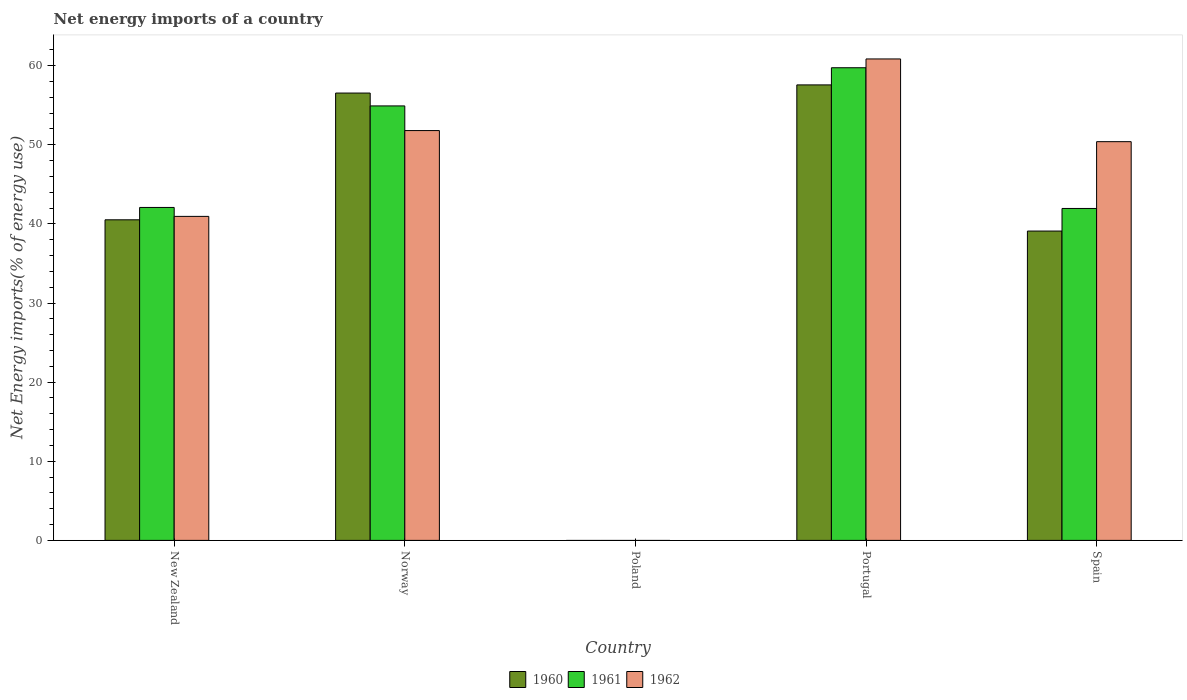Are the number of bars per tick equal to the number of legend labels?
Provide a succinct answer. No. What is the net energy imports in 1962 in New Zealand?
Offer a very short reply. 40.95. Across all countries, what is the maximum net energy imports in 1961?
Keep it short and to the point. 59.74. What is the total net energy imports in 1960 in the graph?
Make the answer very short. 193.74. What is the difference between the net energy imports in 1961 in New Zealand and that in Norway?
Ensure brevity in your answer.  -12.83. What is the difference between the net energy imports in 1962 in Poland and the net energy imports in 1961 in New Zealand?
Keep it short and to the point. -42.08. What is the average net energy imports in 1960 per country?
Your response must be concise. 38.75. What is the difference between the net energy imports of/in 1960 and net energy imports of/in 1962 in Norway?
Make the answer very short. 4.74. What is the ratio of the net energy imports in 1962 in Norway to that in Spain?
Ensure brevity in your answer.  1.03. Is the difference between the net energy imports in 1960 in New Zealand and Portugal greater than the difference between the net energy imports in 1962 in New Zealand and Portugal?
Keep it short and to the point. Yes. What is the difference between the highest and the second highest net energy imports in 1961?
Offer a terse response. -17.66. What is the difference between the highest and the lowest net energy imports in 1960?
Make the answer very short. 57.57. Are the values on the major ticks of Y-axis written in scientific E-notation?
Make the answer very short. No. Does the graph contain any zero values?
Your answer should be compact. Yes. What is the title of the graph?
Keep it short and to the point. Net energy imports of a country. Does "1977" appear as one of the legend labels in the graph?
Keep it short and to the point. No. What is the label or title of the X-axis?
Offer a very short reply. Country. What is the label or title of the Y-axis?
Ensure brevity in your answer.  Net Energy imports(% of energy use). What is the Net Energy imports(% of energy use) of 1960 in New Zealand?
Ensure brevity in your answer.  40.52. What is the Net Energy imports(% of energy use) in 1961 in New Zealand?
Your answer should be very brief. 42.08. What is the Net Energy imports(% of energy use) of 1962 in New Zealand?
Give a very brief answer. 40.95. What is the Net Energy imports(% of energy use) of 1960 in Norway?
Provide a short and direct response. 56.54. What is the Net Energy imports(% of energy use) of 1961 in Norway?
Give a very brief answer. 54.92. What is the Net Energy imports(% of energy use) of 1962 in Norway?
Your answer should be very brief. 51.8. What is the Net Energy imports(% of energy use) of 1960 in Poland?
Offer a very short reply. 0. What is the Net Energy imports(% of energy use) of 1961 in Poland?
Ensure brevity in your answer.  0. What is the Net Energy imports(% of energy use) of 1960 in Portugal?
Make the answer very short. 57.57. What is the Net Energy imports(% of energy use) of 1961 in Portugal?
Your response must be concise. 59.74. What is the Net Energy imports(% of energy use) in 1962 in Portugal?
Your answer should be very brief. 60.85. What is the Net Energy imports(% of energy use) in 1960 in Spain?
Provide a succinct answer. 39.1. What is the Net Energy imports(% of energy use) of 1961 in Spain?
Make the answer very short. 41.95. What is the Net Energy imports(% of energy use) of 1962 in Spain?
Give a very brief answer. 50.4. Across all countries, what is the maximum Net Energy imports(% of energy use) of 1960?
Ensure brevity in your answer.  57.57. Across all countries, what is the maximum Net Energy imports(% of energy use) in 1961?
Ensure brevity in your answer.  59.74. Across all countries, what is the maximum Net Energy imports(% of energy use) in 1962?
Your answer should be compact. 60.85. Across all countries, what is the minimum Net Energy imports(% of energy use) of 1960?
Make the answer very short. 0. Across all countries, what is the minimum Net Energy imports(% of energy use) in 1961?
Keep it short and to the point. 0. What is the total Net Energy imports(% of energy use) in 1960 in the graph?
Your answer should be compact. 193.74. What is the total Net Energy imports(% of energy use) in 1961 in the graph?
Ensure brevity in your answer.  198.7. What is the total Net Energy imports(% of energy use) in 1962 in the graph?
Ensure brevity in your answer.  204.01. What is the difference between the Net Energy imports(% of energy use) of 1960 in New Zealand and that in Norway?
Give a very brief answer. -16.02. What is the difference between the Net Energy imports(% of energy use) of 1961 in New Zealand and that in Norway?
Make the answer very short. -12.83. What is the difference between the Net Energy imports(% of energy use) of 1962 in New Zealand and that in Norway?
Your response must be concise. -10.85. What is the difference between the Net Energy imports(% of energy use) in 1960 in New Zealand and that in Portugal?
Offer a terse response. -17.05. What is the difference between the Net Energy imports(% of energy use) of 1961 in New Zealand and that in Portugal?
Ensure brevity in your answer.  -17.66. What is the difference between the Net Energy imports(% of energy use) of 1962 in New Zealand and that in Portugal?
Your response must be concise. -19.9. What is the difference between the Net Energy imports(% of energy use) in 1960 in New Zealand and that in Spain?
Give a very brief answer. 1.42. What is the difference between the Net Energy imports(% of energy use) of 1961 in New Zealand and that in Spain?
Provide a short and direct response. 0.13. What is the difference between the Net Energy imports(% of energy use) of 1962 in New Zealand and that in Spain?
Give a very brief answer. -9.45. What is the difference between the Net Energy imports(% of energy use) of 1960 in Norway and that in Portugal?
Give a very brief answer. -1.03. What is the difference between the Net Energy imports(% of energy use) in 1961 in Norway and that in Portugal?
Offer a very short reply. -4.83. What is the difference between the Net Energy imports(% of energy use) in 1962 in Norway and that in Portugal?
Offer a very short reply. -9.05. What is the difference between the Net Energy imports(% of energy use) in 1960 in Norway and that in Spain?
Offer a very short reply. 17.44. What is the difference between the Net Energy imports(% of energy use) in 1961 in Norway and that in Spain?
Offer a very short reply. 12.96. What is the difference between the Net Energy imports(% of energy use) of 1962 in Norway and that in Spain?
Offer a very short reply. 1.4. What is the difference between the Net Energy imports(% of energy use) of 1960 in Portugal and that in Spain?
Ensure brevity in your answer.  18.47. What is the difference between the Net Energy imports(% of energy use) in 1961 in Portugal and that in Spain?
Offer a terse response. 17.79. What is the difference between the Net Energy imports(% of energy use) in 1962 in Portugal and that in Spain?
Offer a terse response. 10.46. What is the difference between the Net Energy imports(% of energy use) in 1960 in New Zealand and the Net Energy imports(% of energy use) in 1961 in Norway?
Your answer should be very brief. -14.39. What is the difference between the Net Energy imports(% of energy use) in 1960 in New Zealand and the Net Energy imports(% of energy use) in 1962 in Norway?
Offer a very short reply. -11.28. What is the difference between the Net Energy imports(% of energy use) in 1961 in New Zealand and the Net Energy imports(% of energy use) in 1962 in Norway?
Keep it short and to the point. -9.72. What is the difference between the Net Energy imports(% of energy use) of 1960 in New Zealand and the Net Energy imports(% of energy use) of 1961 in Portugal?
Keep it short and to the point. -19.22. What is the difference between the Net Energy imports(% of energy use) in 1960 in New Zealand and the Net Energy imports(% of energy use) in 1962 in Portugal?
Offer a terse response. -20.33. What is the difference between the Net Energy imports(% of energy use) of 1961 in New Zealand and the Net Energy imports(% of energy use) of 1962 in Portugal?
Ensure brevity in your answer.  -18.77. What is the difference between the Net Energy imports(% of energy use) in 1960 in New Zealand and the Net Energy imports(% of energy use) in 1961 in Spain?
Ensure brevity in your answer.  -1.43. What is the difference between the Net Energy imports(% of energy use) of 1960 in New Zealand and the Net Energy imports(% of energy use) of 1962 in Spain?
Your response must be concise. -9.88. What is the difference between the Net Energy imports(% of energy use) in 1961 in New Zealand and the Net Energy imports(% of energy use) in 1962 in Spain?
Your response must be concise. -8.32. What is the difference between the Net Energy imports(% of energy use) in 1960 in Norway and the Net Energy imports(% of energy use) in 1961 in Portugal?
Your response must be concise. -3.2. What is the difference between the Net Energy imports(% of energy use) in 1960 in Norway and the Net Energy imports(% of energy use) in 1962 in Portugal?
Offer a very short reply. -4.31. What is the difference between the Net Energy imports(% of energy use) of 1961 in Norway and the Net Energy imports(% of energy use) of 1962 in Portugal?
Give a very brief answer. -5.94. What is the difference between the Net Energy imports(% of energy use) of 1960 in Norway and the Net Energy imports(% of energy use) of 1961 in Spain?
Provide a succinct answer. 14.59. What is the difference between the Net Energy imports(% of energy use) of 1960 in Norway and the Net Energy imports(% of energy use) of 1962 in Spain?
Keep it short and to the point. 6.14. What is the difference between the Net Energy imports(% of energy use) in 1961 in Norway and the Net Energy imports(% of energy use) in 1962 in Spain?
Your answer should be compact. 4.52. What is the difference between the Net Energy imports(% of energy use) in 1960 in Portugal and the Net Energy imports(% of energy use) in 1961 in Spain?
Your response must be concise. 15.62. What is the difference between the Net Energy imports(% of energy use) in 1960 in Portugal and the Net Energy imports(% of energy use) in 1962 in Spain?
Provide a succinct answer. 7.18. What is the difference between the Net Energy imports(% of energy use) of 1961 in Portugal and the Net Energy imports(% of energy use) of 1962 in Spain?
Your response must be concise. 9.34. What is the average Net Energy imports(% of energy use) in 1960 per country?
Make the answer very short. 38.75. What is the average Net Energy imports(% of energy use) in 1961 per country?
Offer a very short reply. 39.74. What is the average Net Energy imports(% of energy use) in 1962 per country?
Ensure brevity in your answer.  40.8. What is the difference between the Net Energy imports(% of energy use) in 1960 and Net Energy imports(% of energy use) in 1961 in New Zealand?
Make the answer very short. -1.56. What is the difference between the Net Energy imports(% of energy use) of 1960 and Net Energy imports(% of energy use) of 1962 in New Zealand?
Keep it short and to the point. -0.43. What is the difference between the Net Energy imports(% of energy use) of 1961 and Net Energy imports(% of energy use) of 1962 in New Zealand?
Provide a short and direct response. 1.13. What is the difference between the Net Energy imports(% of energy use) of 1960 and Net Energy imports(% of energy use) of 1961 in Norway?
Your response must be concise. 1.62. What is the difference between the Net Energy imports(% of energy use) of 1960 and Net Energy imports(% of energy use) of 1962 in Norway?
Give a very brief answer. 4.74. What is the difference between the Net Energy imports(% of energy use) in 1961 and Net Energy imports(% of energy use) in 1962 in Norway?
Keep it short and to the point. 3.12. What is the difference between the Net Energy imports(% of energy use) of 1960 and Net Energy imports(% of energy use) of 1961 in Portugal?
Give a very brief answer. -2.17. What is the difference between the Net Energy imports(% of energy use) in 1960 and Net Energy imports(% of energy use) in 1962 in Portugal?
Provide a succinct answer. -3.28. What is the difference between the Net Energy imports(% of energy use) in 1961 and Net Energy imports(% of energy use) in 1962 in Portugal?
Your answer should be very brief. -1.11. What is the difference between the Net Energy imports(% of energy use) in 1960 and Net Energy imports(% of energy use) in 1961 in Spain?
Ensure brevity in your answer.  -2.85. What is the difference between the Net Energy imports(% of energy use) in 1960 and Net Energy imports(% of energy use) in 1962 in Spain?
Provide a succinct answer. -11.3. What is the difference between the Net Energy imports(% of energy use) in 1961 and Net Energy imports(% of energy use) in 1962 in Spain?
Your response must be concise. -8.44. What is the ratio of the Net Energy imports(% of energy use) in 1960 in New Zealand to that in Norway?
Give a very brief answer. 0.72. What is the ratio of the Net Energy imports(% of energy use) in 1961 in New Zealand to that in Norway?
Ensure brevity in your answer.  0.77. What is the ratio of the Net Energy imports(% of energy use) of 1962 in New Zealand to that in Norway?
Your answer should be very brief. 0.79. What is the ratio of the Net Energy imports(% of energy use) in 1960 in New Zealand to that in Portugal?
Your response must be concise. 0.7. What is the ratio of the Net Energy imports(% of energy use) in 1961 in New Zealand to that in Portugal?
Keep it short and to the point. 0.7. What is the ratio of the Net Energy imports(% of energy use) in 1962 in New Zealand to that in Portugal?
Make the answer very short. 0.67. What is the ratio of the Net Energy imports(% of energy use) of 1960 in New Zealand to that in Spain?
Your answer should be very brief. 1.04. What is the ratio of the Net Energy imports(% of energy use) of 1961 in New Zealand to that in Spain?
Provide a succinct answer. 1. What is the ratio of the Net Energy imports(% of energy use) in 1962 in New Zealand to that in Spain?
Your answer should be very brief. 0.81. What is the ratio of the Net Energy imports(% of energy use) in 1960 in Norway to that in Portugal?
Provide a short and direct response. 0.98. What is the ratio of the Net Energy imports(% of energy use) of 1961 in Norway to that in Portugal?
Provide a short and direct response. 0.92. What is the ratio of the Net Energy imports(% of energy use) in 1962 in Norway to that in Portugal?
Offer a terse response. 0.85. What is the ratio of the Net Energy imports(% of energy use) of 1960 in Norway to that in Spain?
Give a very brief answer. 1.45. What is the ratio of the Net Energy imports(% of energy use) in 1961 in Norway to that in Spain?
Offer a terse response. 1.31. What is the ratio of the Net Energy imports(% of energy use) of 1962 in Norway to that in Spain?
Your answer should be very brief. 1.03. What is the ratio of the Net Energy imports(% of energy use) of 1960 in Portugal to that in Spain?
Make the answer very short. 1.47. What is the ratio of the Net Energy imports(% of energy use) of 1961 in Portugal to that in Spain?
Offer a terse response. 1.42. What is the ratio of the Net Energy imports(% of energy use) in 1962 in Portugal to that in Spain?
Provide a succinct answer. 1.21. What is the difference between the highest and the second highest Net Energy imports(% of energy use) of 1960?
Your answer should be compact. 1.03. What is the difference between the highest and the second highest Net Energy imports(% of energy use) in 1961?
Make the answer very short. 4.83. What is the difference between the highest and the second highest Net Energy imports(% of energy use) in 1962?
Offer a very short reply. 9.05. What is the difference between the highest and the lowest Net Energy imports(% of energy use) of 1960?
Your response must be concise. 57.57. What is the difference between the highest and the lowest Net Energy imports(% of energy use) of 1961?
Keep it short and to the point. 59.74. What is the difference between the highest and the lowest Net Energy imports(% of energy use) of 1962?
Keep it short and to the point. 60.85. 